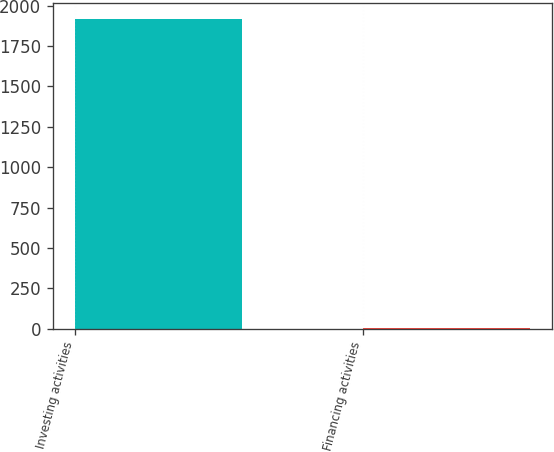<chart> <loc_0><loc_0><loc_500><loc_500><bar_chart><fcel>Investing activities<fcel>Financing activities<nl><fcel>1919<fcel>6<nl></chart> 